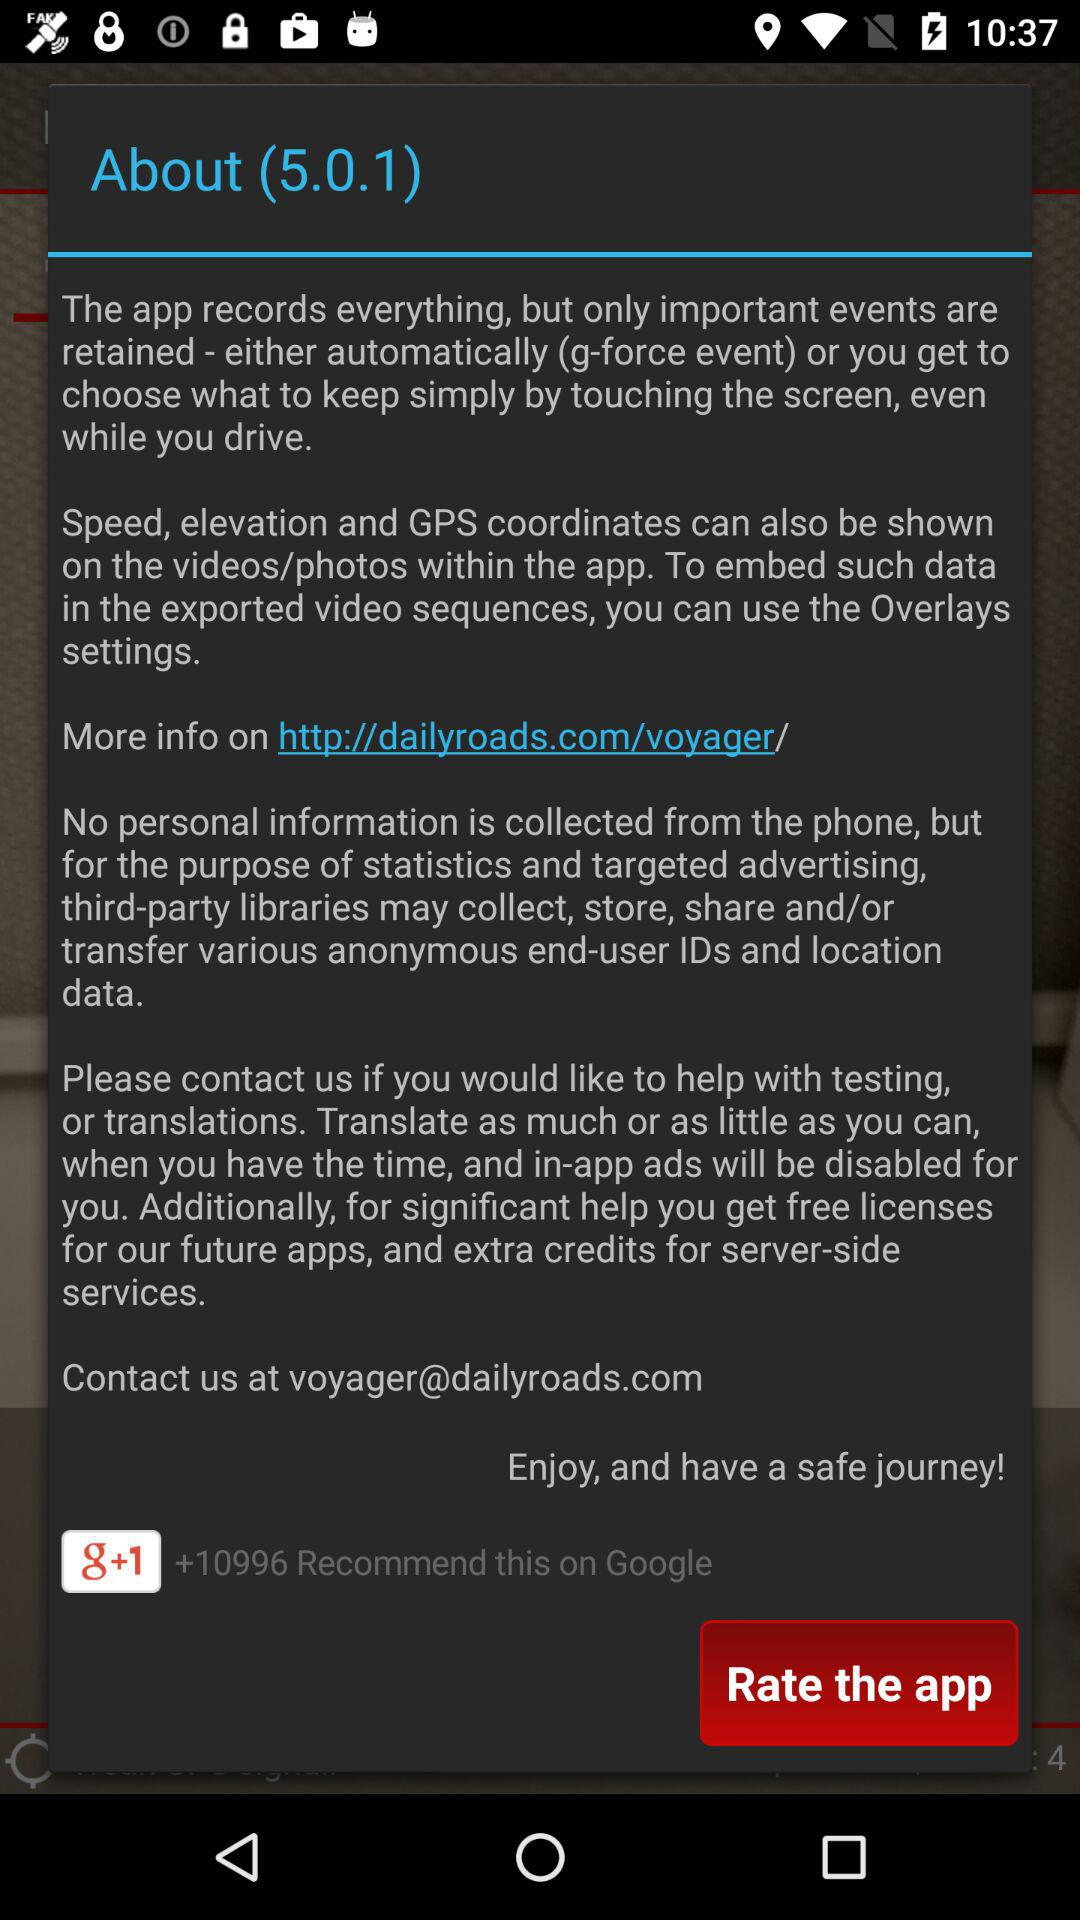What is the more information website address? The web address is "http://dailyroads.com/voyager/". 